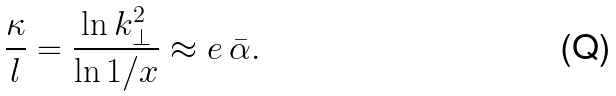<formula> <loc_0><loc_0><loc_500><loc_500>\frac { \kappa } { l } = \frac { \ln k _ { \perp } ^ { 2 } } { \ln 1 / x } \approx e \, \bar { \alpha } .</formula> 